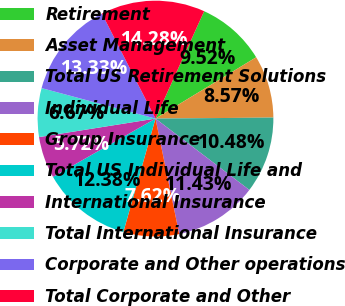Convert chart to OTSL. <chart><loc_0><loc_0><loc_500><loc_500><pie_chart><fcel>Retirement<fcel>Asset Management<fcel>Total US Retirement Solutions<fcel>Individual Life<fcel>Group Insurance<fcel>Total US Individual Life and<fcel>International Insurance<fcel>Total International Insurance<fcel>Corporate and Other operations<fcel>Total Corporate and Other<nl><fcel>9.52%<fcel>8.57%<fcel>10.48%<fcel>11.43%<fcel>7.62%<fcel>12.38%<fcel>5.72%<fcel>6.67%<fcel>13.33%<fcel>14.28%<nl></chart> 